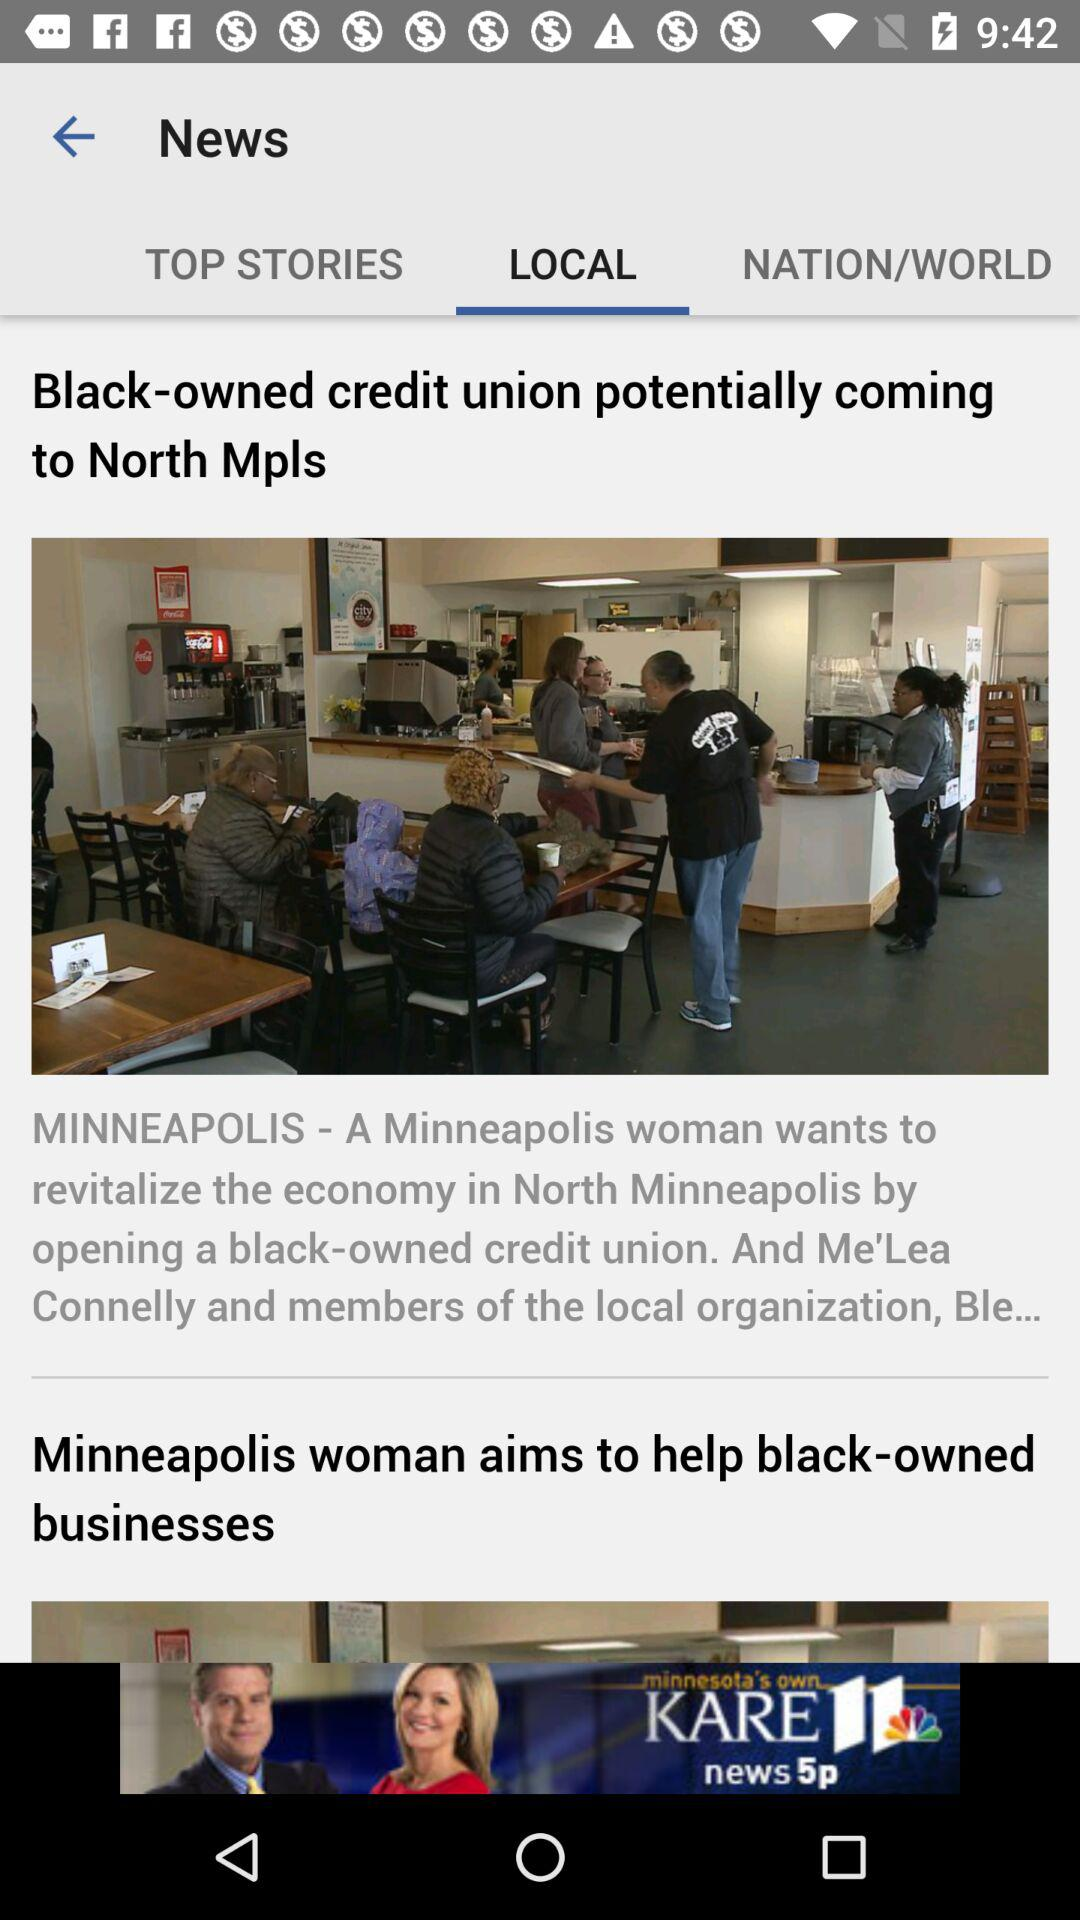Which tab is selected? The selected tab is "LOCAL". 